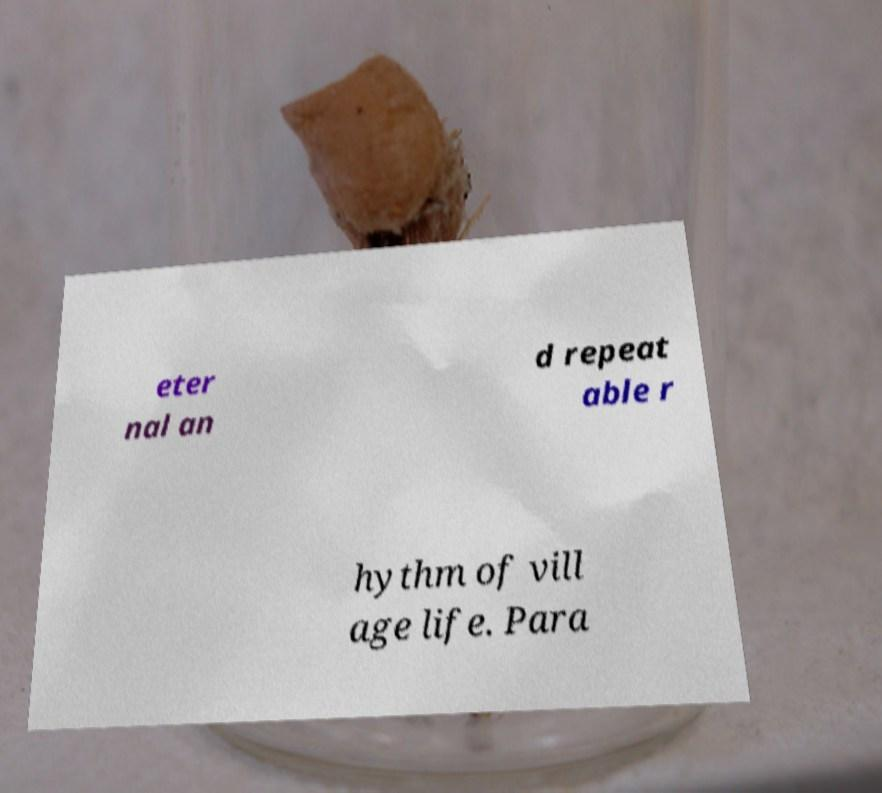Could you extract and type out the text from this image? eter nal an d repeat able r hythm of vill age life. Para 